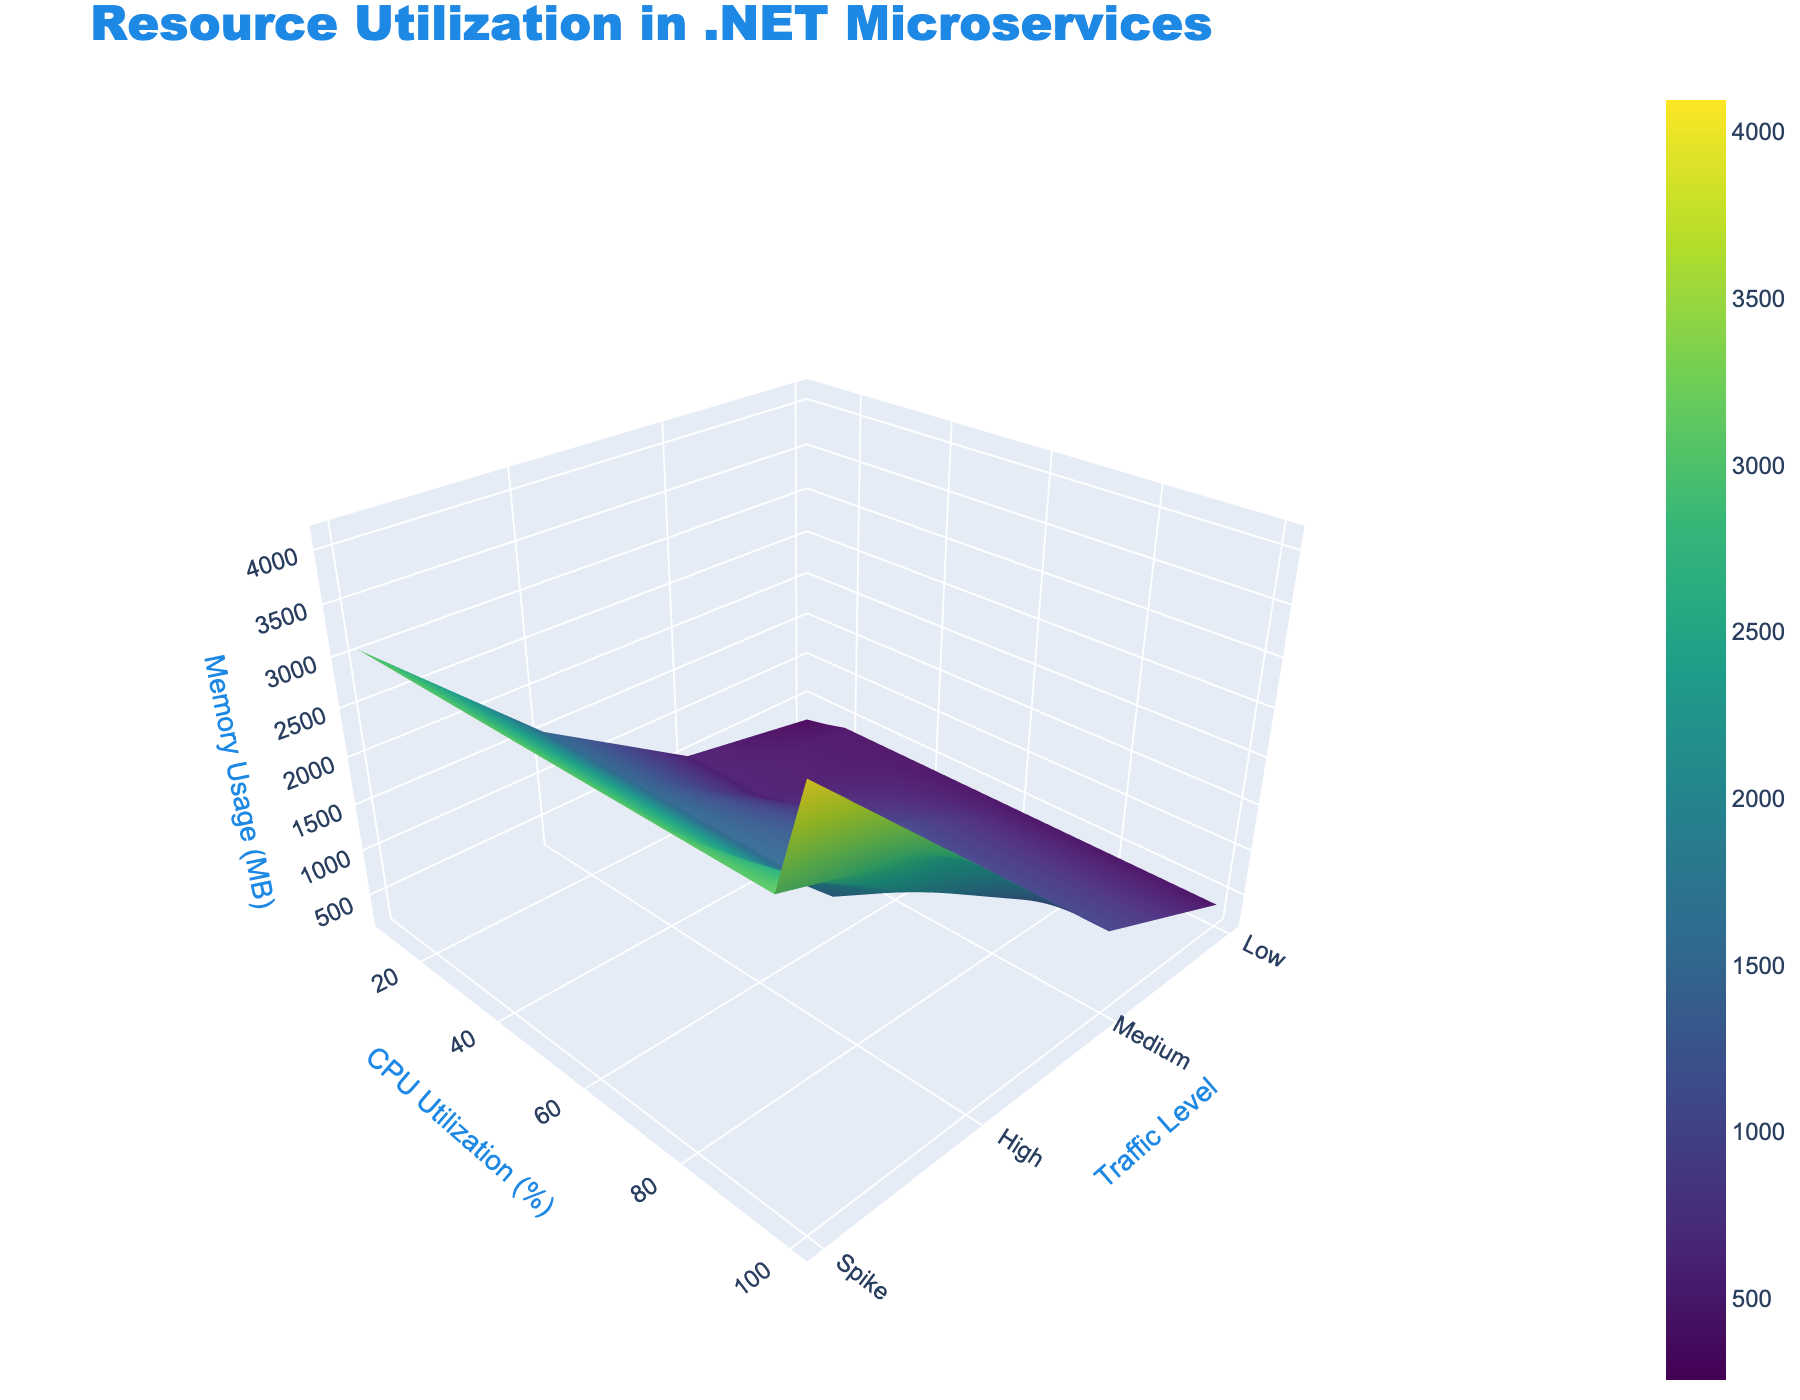What is the title of the 3D surface plot? The title of the plot is usually displayed prominently at the top of the figure. Here, it should indicate the main subject of the figure.
Answer: Resource Utilization in .NET Microservices How many different traffic levels are represented in the plot? The x-axis tick text denotes the different traffic levels. Count these tick texts to determine the number of traffic levels.
Answer: 4 At which traffic level is the highest memory usage observed? Move along the x-axis to identify the traffic level where the z-axis (memory usage) reaches its highest peak.
Answer: Spike What is the CPU utilization in percentage that corresponds to the memory usage of 1024 MB at Medium traffic level? Locate the Medium traffic level on the x-axis, follow until you reach the z-axis value of 1024 MB, and then find the corresponding y-axis value.
Answer: 60% How does memory usage change from Low traffic to Spike traffic when CPU utilization is at 100%? Compare memory usage represented on the z-axis for 100% CPU utilization between Low and Spike traffic levels on the x-axis.
Answer: Increases from 0 to 4096 MB At Low traffic level, what is the memory usage when CPU utilization is 15%? Go to the Low traffic level, follow this along the y-axis to find 15% CPU utilization, and then read the corresponding value on the z-axis for memory usage.
Answer: 312 MB Which traffic level shows the most drastic increase in memory usage with respect to CPU utilization? Examine each traffic level's trend line on the surface plot and identify which shows the steepest gradient.
Answer: Spike Can you compare the CPU utilization at Low and Spike traffic levels for memory usage of 384 MB? Check the memory usage value of 384 MB on the z-axis, find corresponding points on the surface plot for Low and Spike traffic levels, and note their y-axis (CPU utilization) values.
Answer: Low: 20%, Spike: Not applicable (no corresponding CPU utilization at 384 MB in Spike) What is the color scheme used in the plot? Look at the legend or color distribution on the surface plot to determine the color scheme.
Answer: Viridis How does the plot indicate changes in resource utilization? The 3D surface plot uses height (z-axis) and color to reflect variations in resource utilization as traffic level and CPU utilization change on the x and y axes respectively.
Answer: Surface height and color changes 